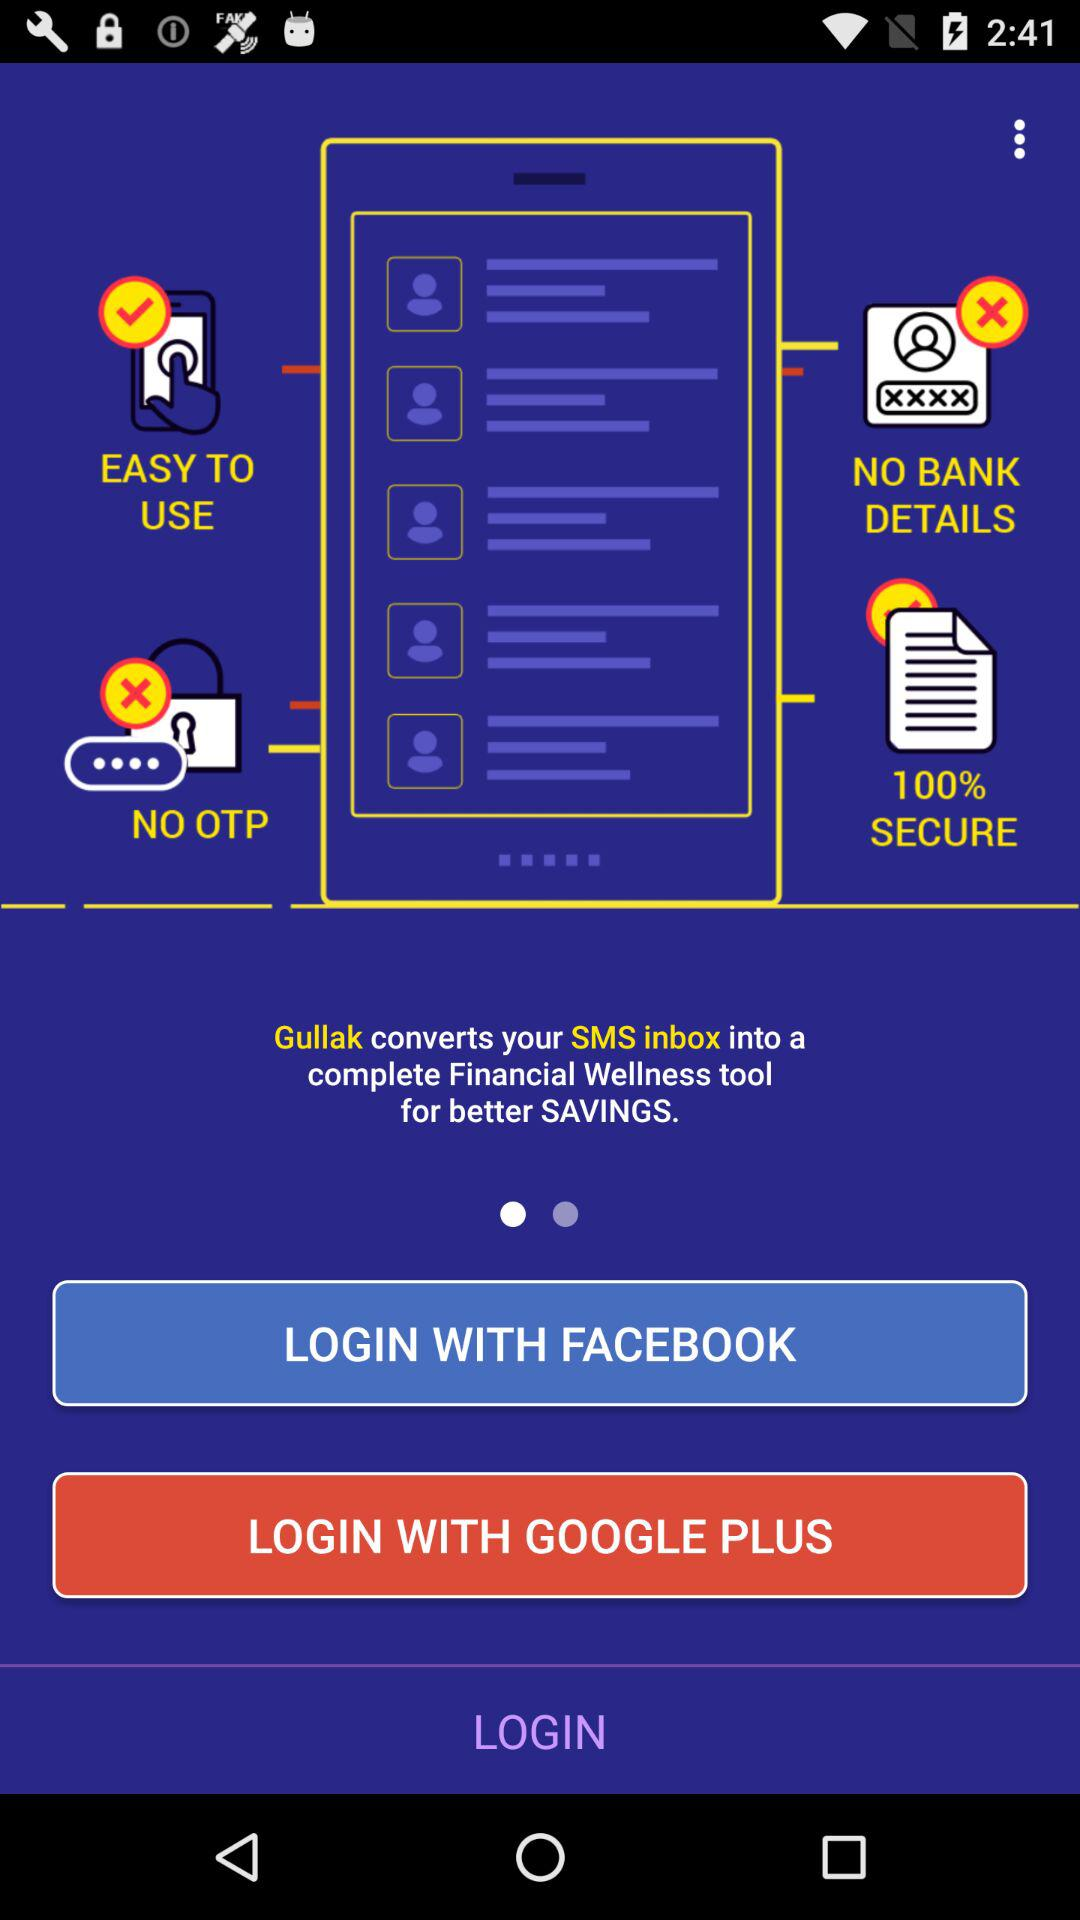What is the name of the application? The name of the application is "Gullak". 